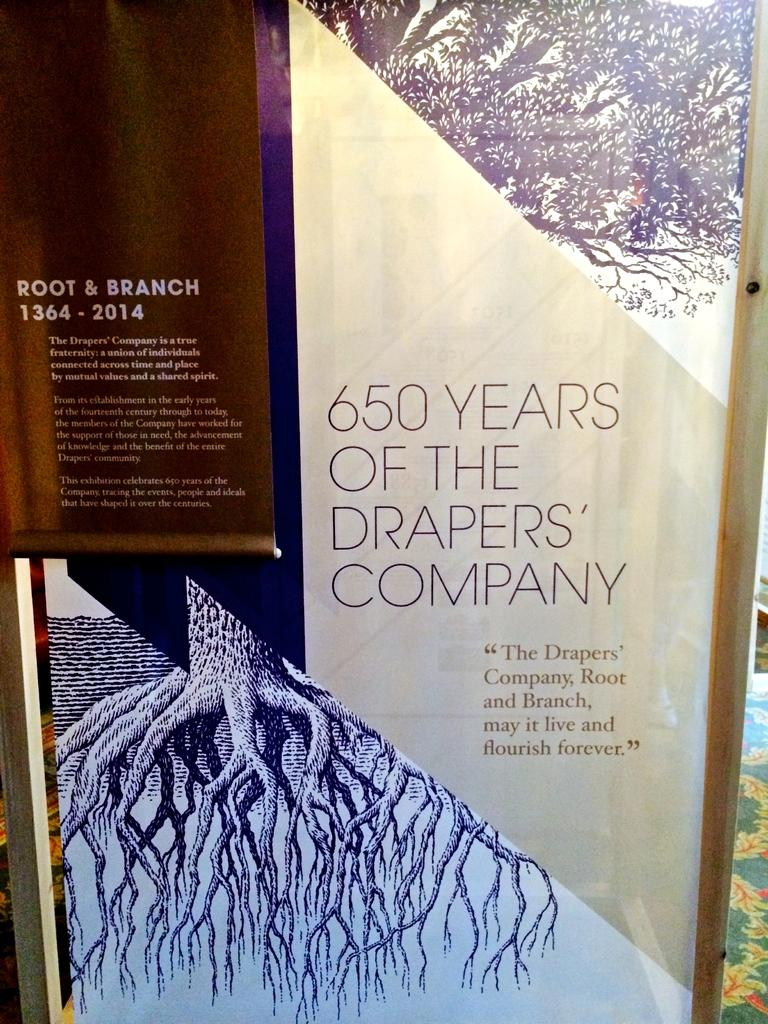<image>
Offer a succinct explanation of the picture presented. a book that says '650 years of the drapers' company' on it 